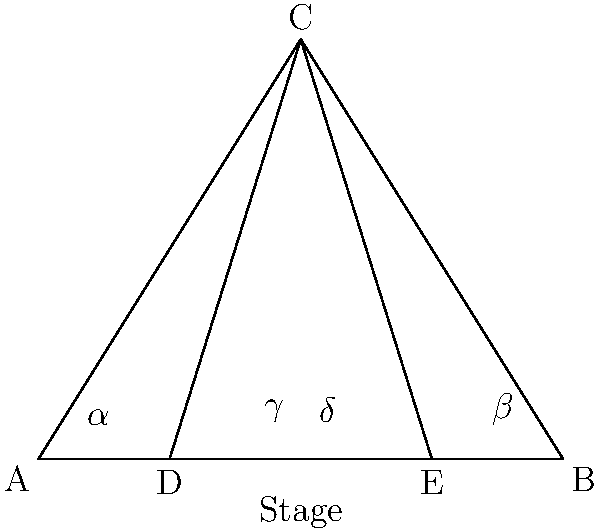In a Broadway theater, the stage is represented by line segment AB, and point C represents the highest seat in the theater. Two audience members are seated at points D and E. If the angle of sight from D to the stage ($\alpha + \gamma$) is 60°, and the angle of sight from E to the stage ($\beta + \delta$) is 50°, what is the measure of angle ACB? Let's approach this step-by-step:

1) In triangle ACB, we need to find angle ACB.

2) We know that the sum of angles in a triangle is 180°. So:
   $$\angle CAB + \angle ACB + \angle CBA = 180°$$

3) From the given information:
   $\alpha + \gamma = 60°$
   $\beta + \delta = 50°$

4) $\angle CAB = \alpha + \gamma = 60°$
   $\angle CBA = \beta + \delta = 50°$

5) Now we can substitute these into our equation from step 2:
   $$60° + \angle ACB + 50° = 180°$$

6) Simplifying:
   $$110° + \angle ACB = 180°$$

7) Solving for $\angle ACB$:
   $$\angle ACB = 180° - 110° = 70°$$

Therefore, the measure of angle ACB is 70°.
Answer: 70° 